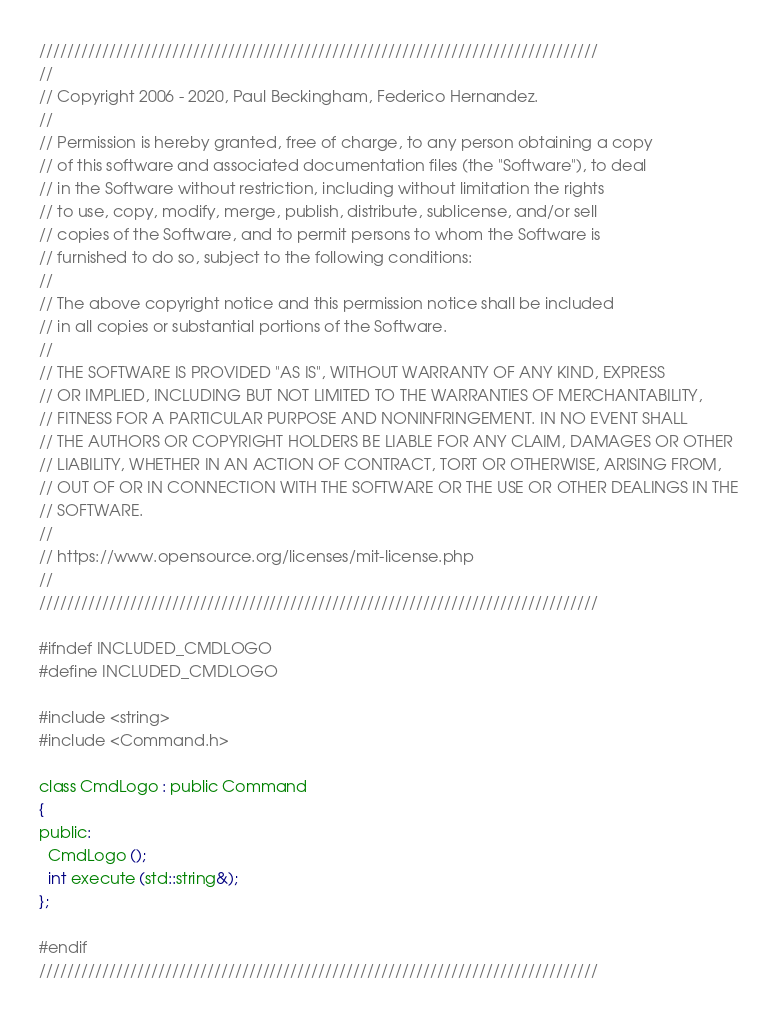Convert code to text. <code><loc_0><loc_0><loc_500><loc_500><_C_>////////////////////////////////////////////////////////////////////////////////
//
// Copyright 2006 - 2020, Paul Beckingham, Federico Hernandez.
//
// Permission is hereby granted, free of charge, to any person obtaining a copy
// of this software and associated documentation files (the "Software"), to deal
// in the Software without restriction, including without limitation the rights
// to use, copy, modify, merge, publish, distribute, sublicense, and/or sell
// copies of the Software, and to permit persons to whom the Software is
// furnished to do so, subject to the following conditions:
//
// The above copyright notice and this permission notice shall be included
// in all copies or substantial portions of the Software.
//
// THE SOFTWARE IS PROVIDED "AS IS", WITHOUT WARRANTY OF ANY KIND, EXPRESS
// OR IMPLIED, INCLUDING BUT NOT LIMITED TO THE WARRANTIES OF MERCHANTABILITY,
// FITNESS FOR A PARTICULAR PURPOSE AND NONINFRINGEMENT. IN NO EVENT SHALL
// THE AUTHORS OR COPYRIGHT HOLDERS BE LIABLE FOR ANY CLAIM, DAMAGES OR OTHER
// LIABILITY, WHETHER IN AN ACTION OF CONTRACT, TORT OR OTHERWISE, ARISING FROM,
// OUT OF OR IN CONNECTION WITH THE SOFTWARE OR THE USE OR OTHER DEALINGS IN THE
// SOFTWARE.
//
// https://www.opensource.org/licenses/mit-license.php
//
////////////////////////////////////////////////////////////////////////////////

#ifndef INCLUDED_CMDLOGO
#define INCLUDED_CMDLOGO

#include <string>
#include <Command.h>

class CmdLogo : public Command
{
public:
  CmdLogo ();
  int execute (std::string&);
};

#endif
////////////////////////////////////////////////////////////////////////////////
</code> 